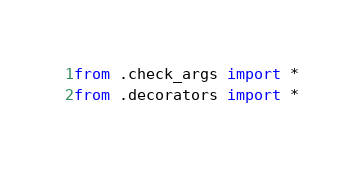Convert code to text. <code><loc_0><loc_0><loc_500><loc_500><_Python_>from .check_args import *
from .decorators import *
</code> 